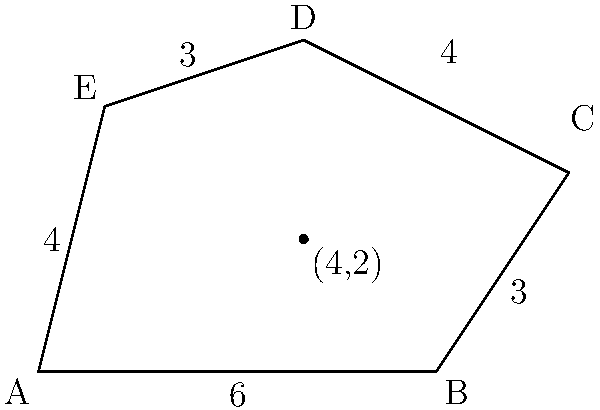As a program officer allocating grants for land development, you need to calculate the area of an irregular land parcel. The parcel is represented by the polygon ABCDE in the diagram. Given that point (4,2) is inside the polygon, calculate the total area of the land parcel using the shoelace formula. Round your answer to the nearest square unit. To calculate the area of the irregular polygon using the shoelace formula, we'll follow these steps:

1) The shoelace formula for the area of a polygon with vertices $(x_1, y_1), (x_2, y_2), ..., (x_n, y_n)$ is:

   $$Area = \frac{1}{2}|(x_1y_2 + x_2y_3 + ... + x_ny_1) - (y_1x_2 + y_2x_3 + ... + y_nx_1)|$$

2) From the diagram, we can identify the coordinates of the vertices:
   A(0,0), B(6,0), C(8,3), D(4,5), E(1,4)

3) Let's apply the formula:

   $$\begin{align*}
   Area &= \frac{1}{2}|(0\cdot0 + 6\cdot3 + 8\cdot5 + 4\cdot4 + 1\cdot0) - (0\cdot6 + 0\cdot8 + 3\cdot4 + 5\cdot1 + 4\cdot0)|\\
   &= \frac{1}{2}|(0 + 18 + 40 + 16 + 0) - (0 + 0 + 12 + 5 + 0)|\\
   &= \frac{1}{2}|74 - 17|\\
   &= \frac{1}{2}\cdot57\\
   &= 28.5
   \end{align*}$$

4) Rounding to the nearest square unit, we get 29 square units.

This method allows us to accurately calculate the area of irregular land parcels, which is crucial for fair grant allocation in land development projects.
Answer: 29 square units 